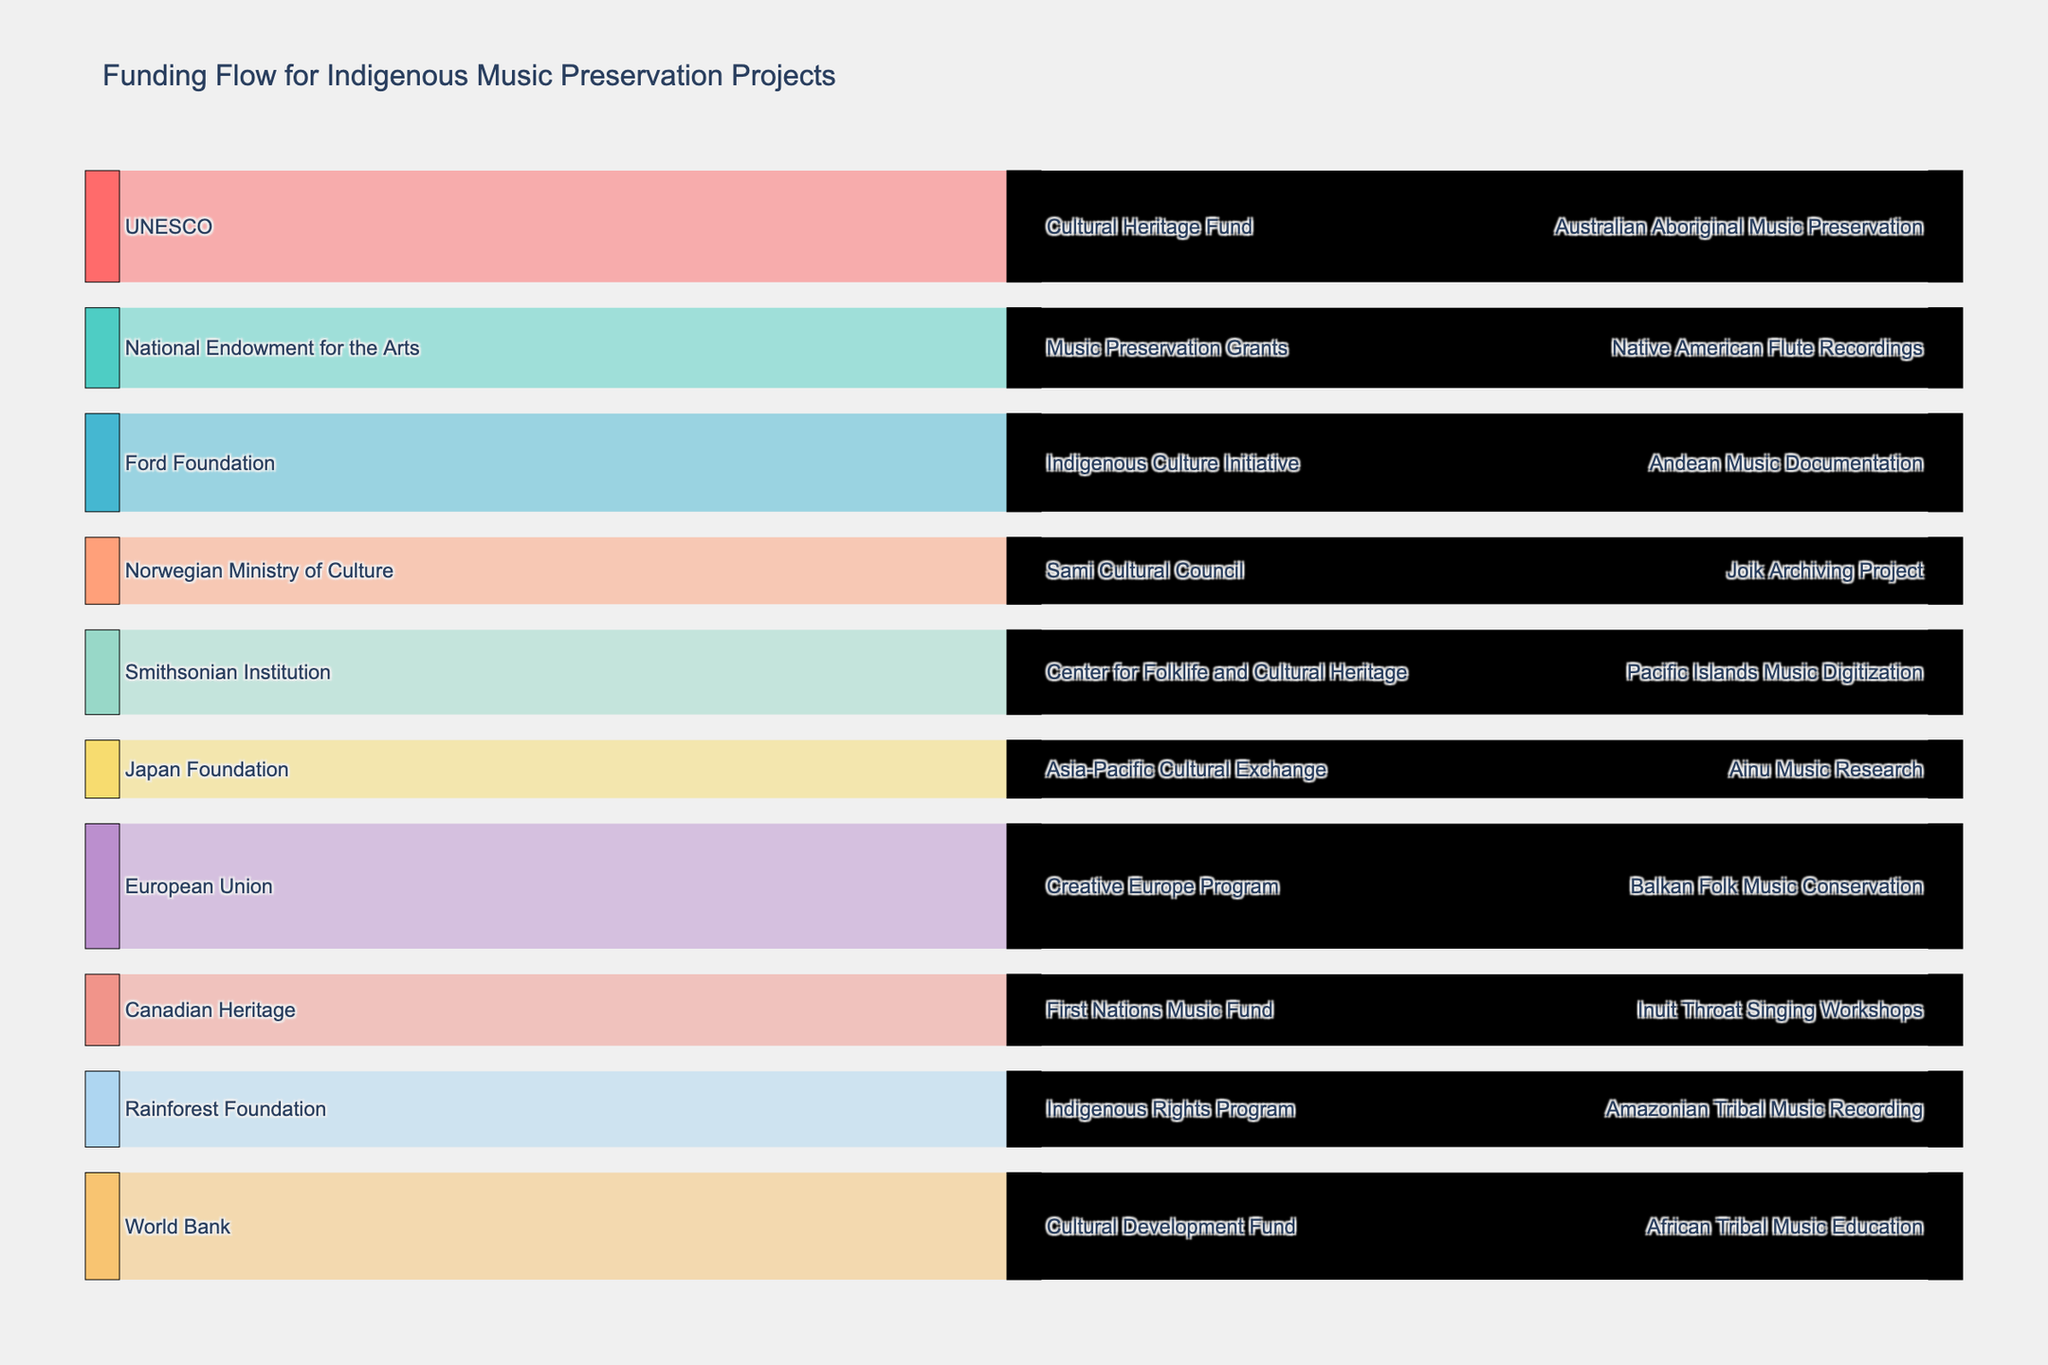Which source has the highest funding value? By looking at the source nodes and their corresponding values, it is evident that the "European Union" contributes the highest value of 2,800,000.
Answer: European Union How much total funding is contributed by "Norwegian Ministry of Culture" and "World Bank"? The funding amounts are 1,500,000 from the "Norwegian Ministry of Culture" and 2,400,000 from the "World Bank". Summing them gives 1,500,000 + 2,400,000 = 3,900,000.
Answer: 3,900,000 Which destination project receives the least amount of funding? By looking at the final nodes representing the destination projects, "Ainu Music Research" has the lowest funding value of 1,300,000.
Answer: Ainu Music Research Compare the funding amounts between "Native American Flute Recordings" and "Pacific Islands Music Digitization". Which one receives more, and by how much? "Native American Flute Recordings" receives 1,800,000 while "Pacific Islands Music Digitization" receives 1,900,000. The difference is 1,900,000 - 1,800,000 = 100,000, so "Pacific Islands Music Digitization" receives 100,000 more.
Answer: Pacific Islands Music Digitization, 100,000 more How many different intermediary funds are involved in the allocation process? Counting the unique nodes labeled as intermediaries in the figure, there are 10 different intermediary funds.
Answer: 10 Which intermediary fund allocates funding to the "Andean Music Documentation" project? By following the flow from intermediary to destination, the "Indigenous Culture Initiative" fund allocates to the "Andean Music Documentation" project.
Answer: Indigenous Culture Initiative What is the total amount of funding drawn from "Center for Folklife and Cultural Heritage" and "Cultural Development Fund"? Both values are 1,900,000 from "Center for Folklife and Cultural Heritage" and 2,400,000 from "Cultural Development Fund". Summing them gives 1,900,000 + 2,400,000 = 4,300,000.
Answer: 4,300,000 Which funding source is connected to the "First Nations Music Fund"? The source node connected to the "First Nations Music Fund" through an intermediary directs to "Canadian Heritage".
Answer: Canadian Heritage What is the combined total funding from all "destination" projects? Summing all destination funding values: 2,500,000 (Australian Aboriginal Music Preservation) + 1,800,000 (Native American Flute Recordings) + 2,200,000 (Andean Music Documentation) + 1,500,000 (Joik Archiving Project) + 1,900,000 (Pacific Islands Music Digitization) + 1,300,000 (Ainu Music Research) + 2,800,000 (Balkan Folk Music Conservation) + 1,600,000 (Inuit Throat Singing Workshops) + 1,700,000 (Amazonian Tribal Music Recording) + 2,400,000 (African Tribal Music Education) = 19,700,000.
Answer: 19,700,000 